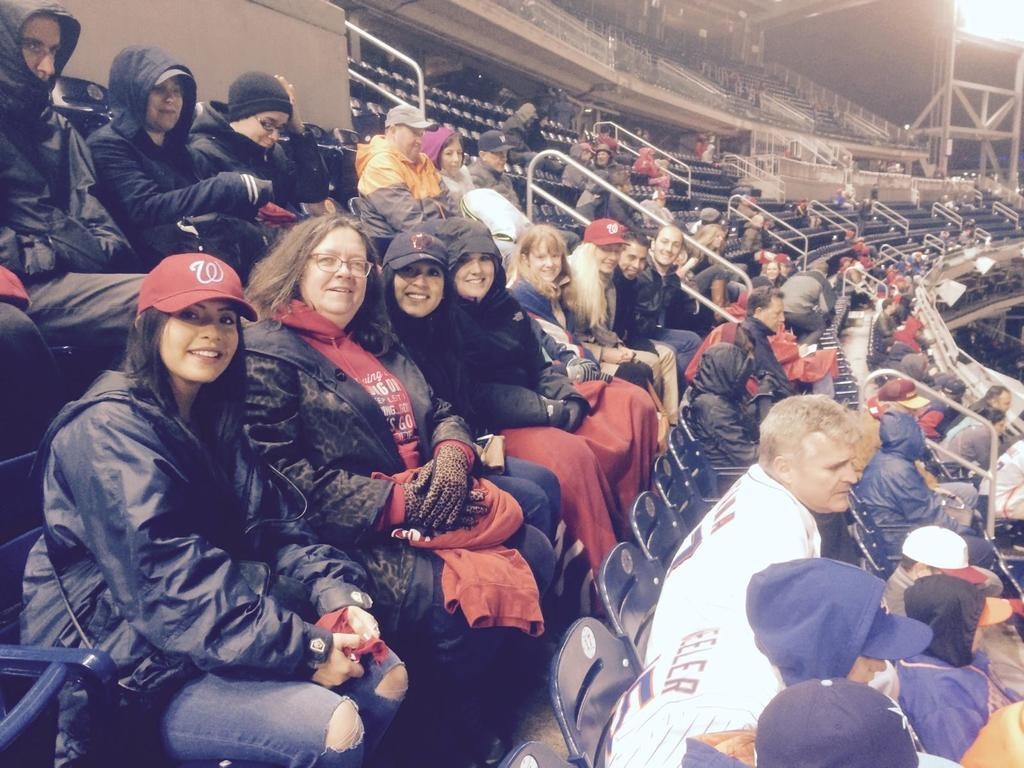What types of people are present in the image? There are men and women in the image. Where are the men and women located in the image? The men and women are sitting in the sitting area of a stadium. What type of joke is being told by the men in the image? There is no indication in the image that a joke is being told, so it cannot be determined from the picture. 